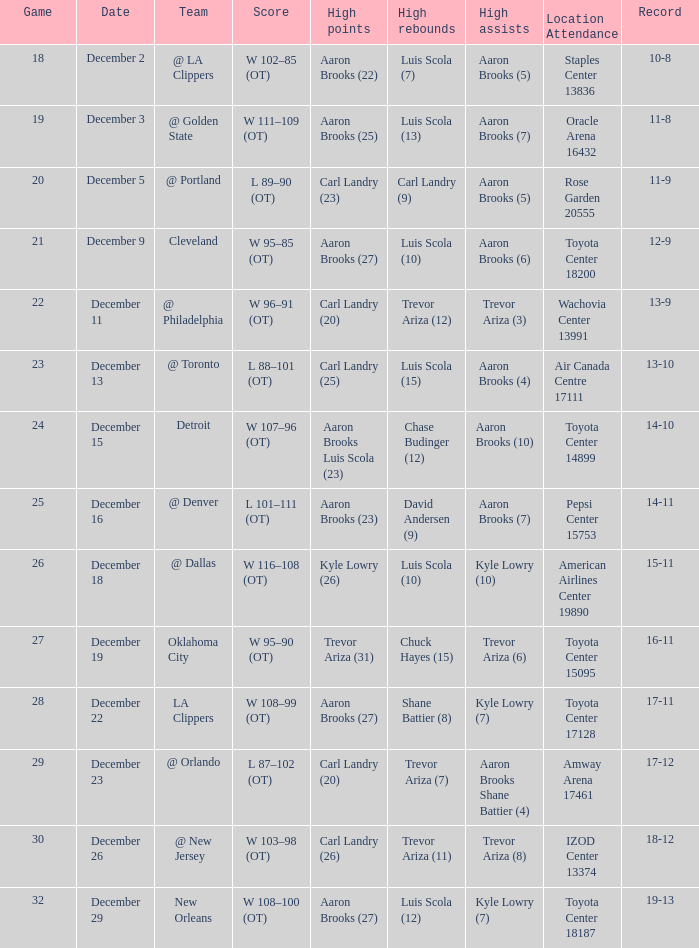In the game where shane battier achieved 8 high rebounds, what was the concluding score? W 108–99 (OT). 